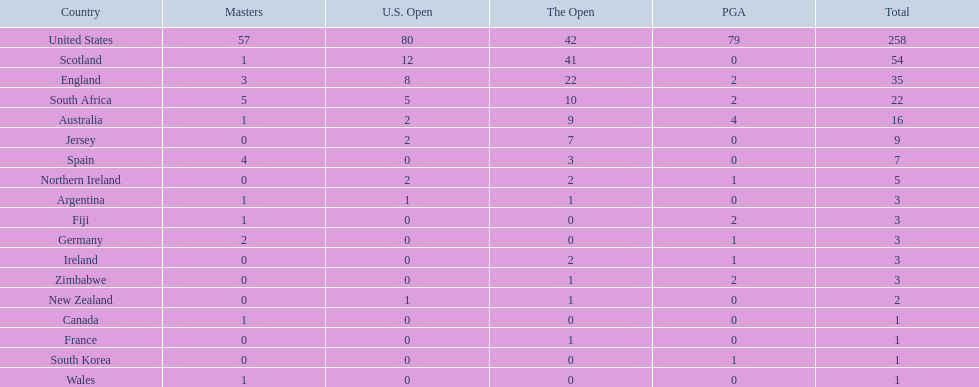What countries in the championship were from africa? South Africa, Zimbabwe. Which of these counteries had the least championship golfers Zimbabwe. 